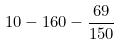<formula> <loc_0><loc_0><loc_500><loc_500>1 0 - 1 6 0 - \frac { 6 9 } { 1 5 0 }</formula> 